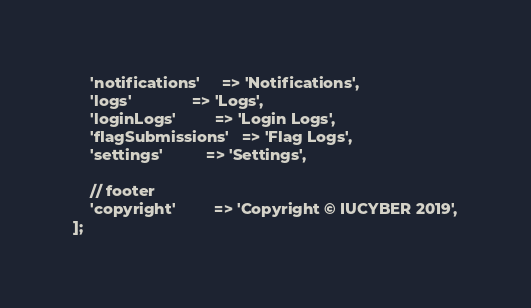Convert code to text. <code><loc_0><loc_0><loc_500><loc_500><_PHP_>	'notifications'		=> 'Notifications',
	'logs'				=> 'Logs',
	'loginLogs'			=> 'Login Logs',
	'flagSubmissions'	=> 'Flag Logs',
	'settings'			=> 'Settings',

	// footer
	'copyright'			=> 'Copyright © IUCYBER 2019',
];
</code> 